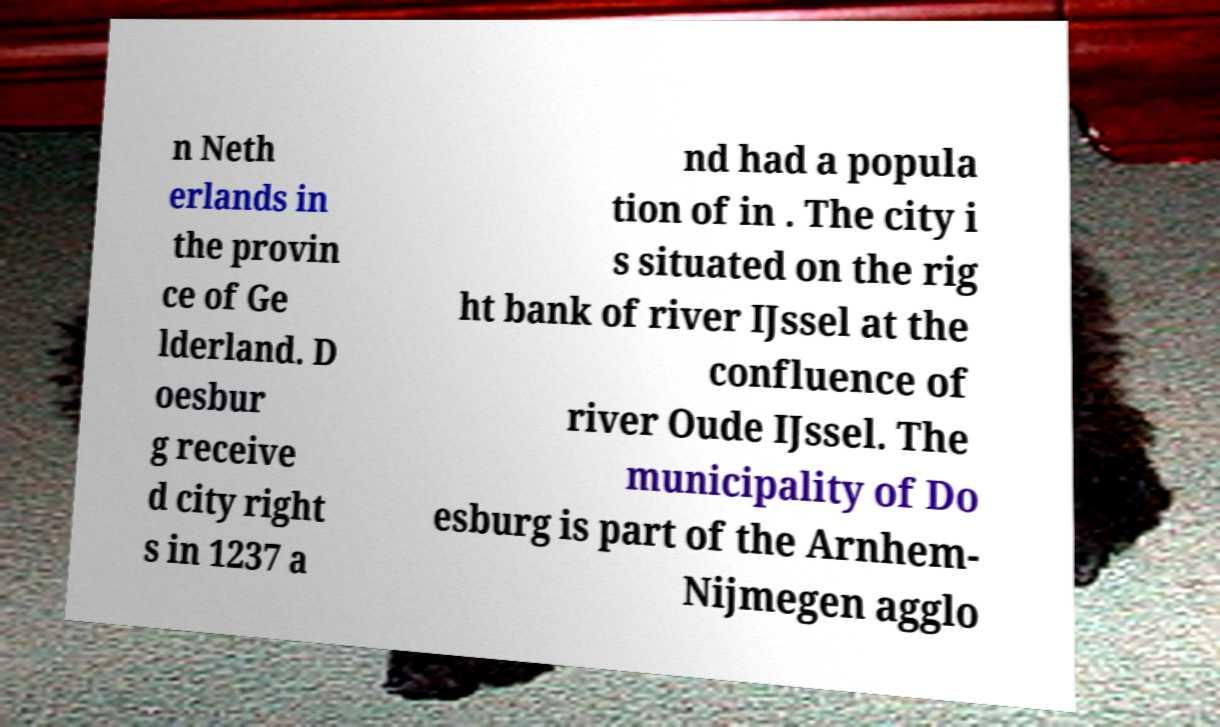What messages or text are displayed in this image? I need them in a readable, typed format. n Neth erlands in the provin ce of Ge lderland. D oesbur g receive d city right s in 1237 a nd had a popula tion of in . The city i s situated on the rig ht bank of river IJssel at the confluence of river Oude IJssel. The municipality of Do esburg is part of the Arnhem- Nijmegen agglo 